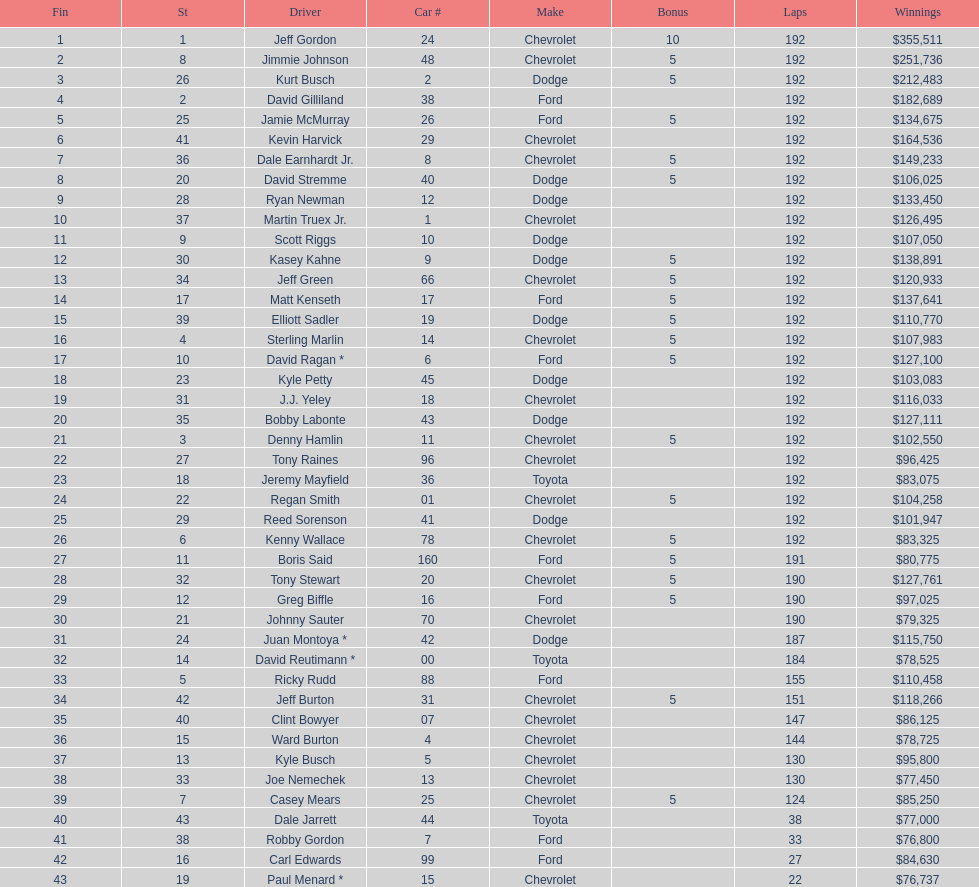What make did kurt busch drive? Dodge. 